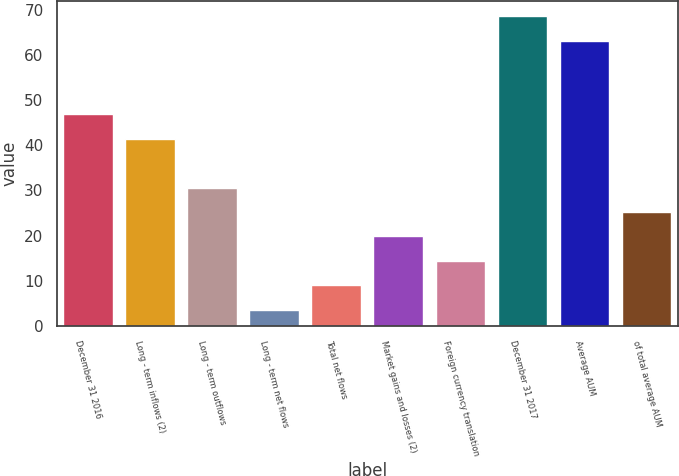<chart> <loc_0><loc_0><loc_500><loc_500><bar_chart><fcel>December 31 2016<fcel>Long - term inflows (2)<fcel>Long - term outflows<fcel>Long - term net flows<fcel>Total net flows<fcel>Market gains and losses (2)<fcel>Foreign currency translation<fcel>December 31 2017<fcel>Average AUM<fcel>of total average AUM<nl><fcel>46.88<fcel>41.47<fcel>30.65<fcel>3.6<fcel>9.01<fcel>19.83<fcel>14.42<fcel>68.52<fcel>63.11<fcel>25.24<nl></chart> 